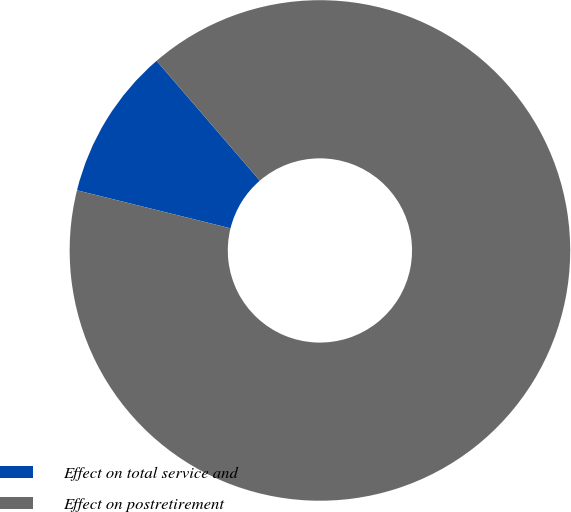<chart> <loc_0><loc_0><loc_500><loc_500><pie_chart><fcel>Effect on total service and<fcel>Effect on postretirement<nl><fcel>9.82%<fcel>90.18%<nl></chart> 